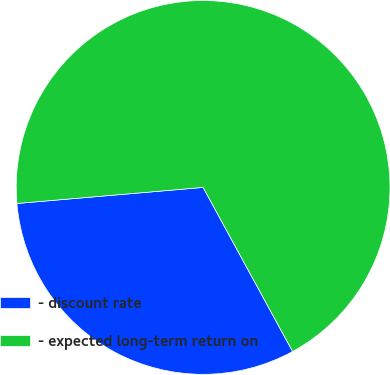<chart> <loc_0><loc_0><loc_500><loc_500><pie_chart><fcel>- discount rate<fcel>- expected long-term return on<nl><fcel>31.58%<fcel>68.42%<nl></chart> 